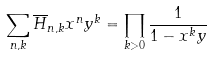Convert formula to latex. <formula><loc_0><loc_0><loc_500><loc_500>\sum _ { n , k } \overline { H } _ { n , k } x ^ { n } y ^ { k } = \prod _ { k > 0 } \frac { 1 } { 1 - x ^ { k } y }</formula> 